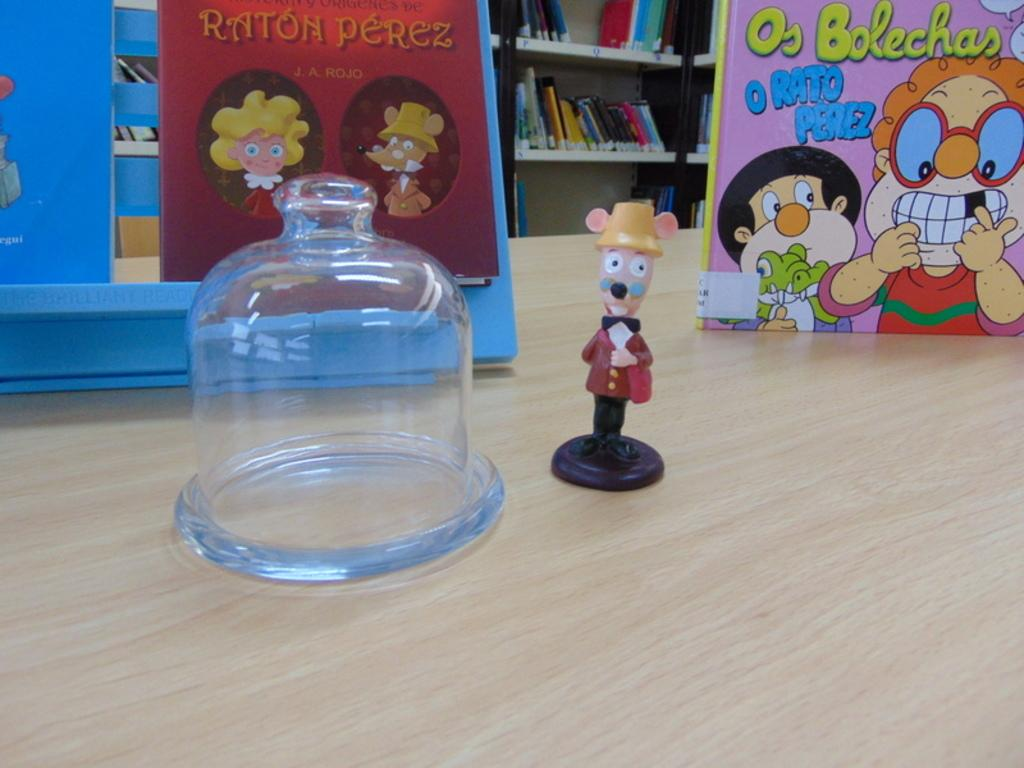<image>
Offer a succinct explanation of the picture presented. A small statue of a mouse in glasses is in front of some books on a table, including Raton Perez. 